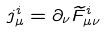<formula> <loc_0><loc_0><loc_500><loc_500>j _ { \mu } ^ { i } = \partial _ { \nu } \widetilde { F } ^ { i } _ { \mu \nu }</formula> 